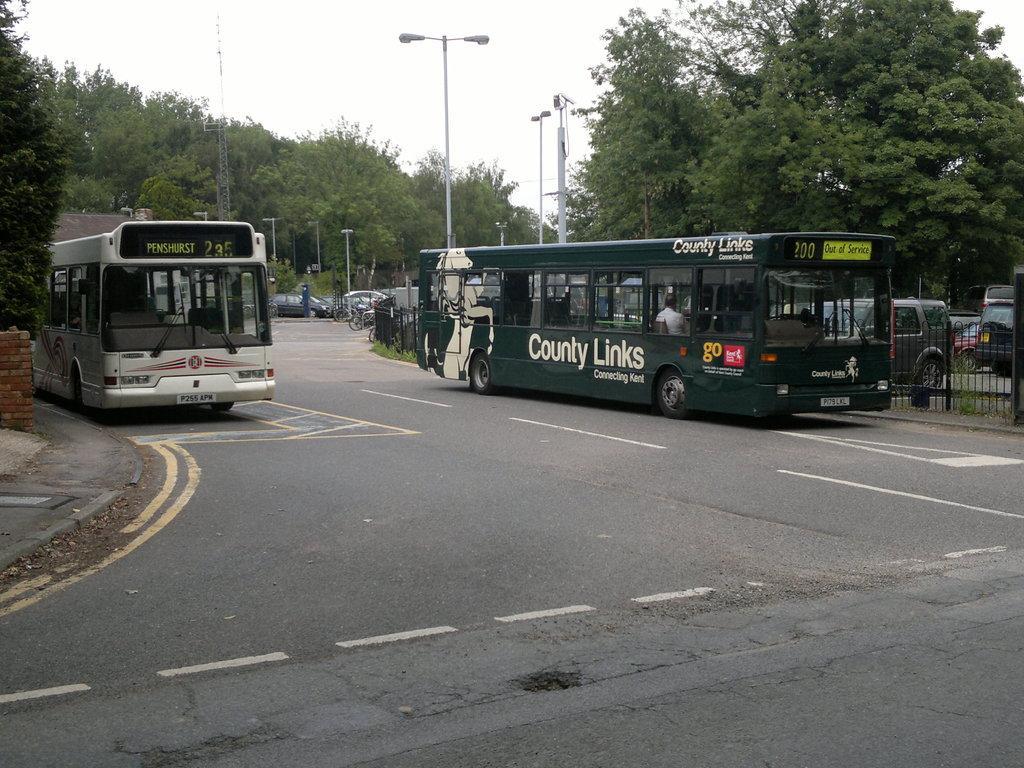Can you describe this image briefly? This picture is clicked outside. In the center we can see the two buses and group of vehicles and we can see the lights attached to the poles. In the background we can see the sky, trees, metal rods and many other objects. 